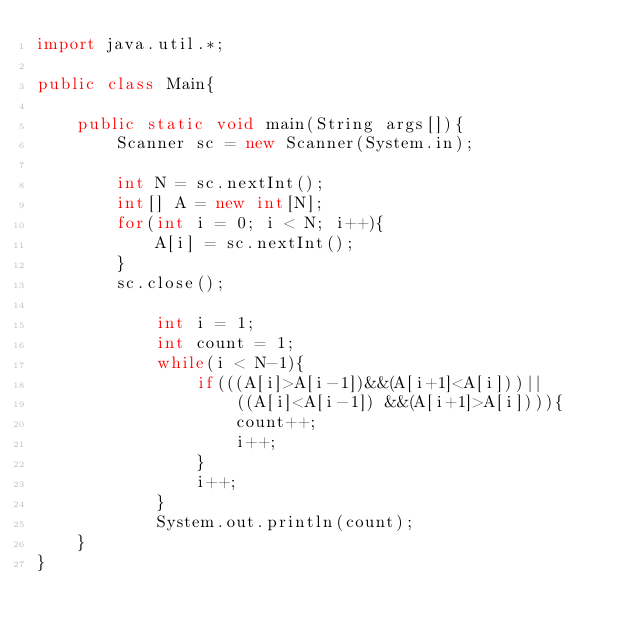Convert code to text. <code><loc_0><loc_0><loc_500><loc_500><_Java_>import java.util.*;

public class Main{
    
    public static void main(String args[]){
        Scanner sc = new Scanner(System.in);

        int N = sc.nextInt();
        int[] A = new int[N];
        for(int i = 0; i < N; i++){
            A[i] = sc.nextInt();
        }
        sc.close();

            int i = 1;
            int count = 1;
            while(i < N-1){
                if(((A[i]>A[i-1])&&(A[i+1]<A[i]))||
                    ((A[i]<A[i-1]) &&(A[i+1]>A[i]))){
                    count++;
                    i++;
                }
                i++;
            }
            System.out.println(count);
    }
}</code> 